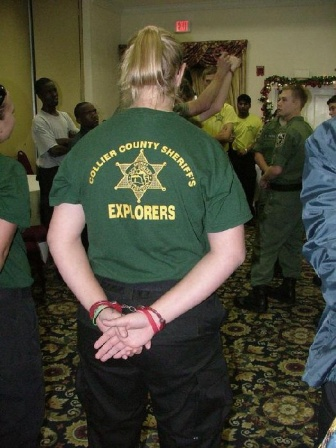What is this photo about? The photo captures a moment in a room where a person wearing a green t-shirt with the words 'Collier County Sheriff's Explorers' stands with their back to the camera, their hands clasped behind them. The individual appears to be observing a group of people standing in a circle, perhaps indicating a supervisory or mentoring role. The surroundings suggest an indoor setting with beige walls and a carpeted floor, adding a neutral backdrop. Festive decorations, including a Christmas tree, hint that this gathering is taking place during the holiday season. The composition of the image provides a sense of depth and perspective and emphasizes social interaction, possibly during a festive event or meeting. 